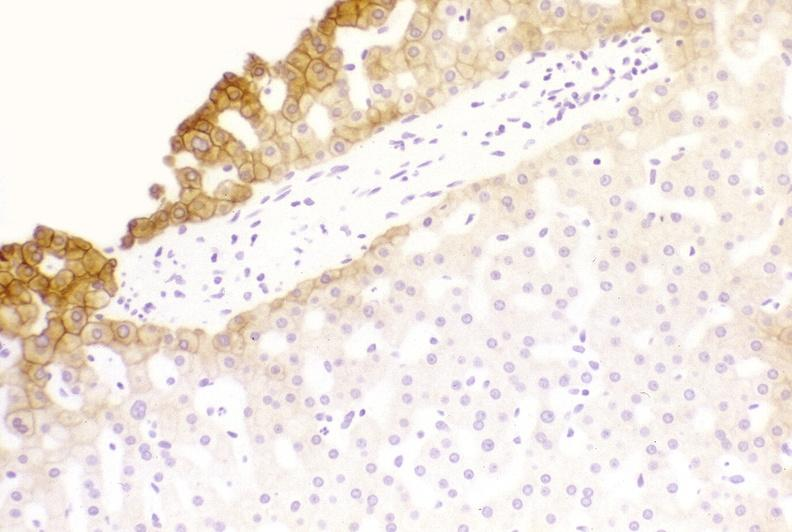does polyarteritis nodosa show low molecular weight keratin?
Answer the question using a single word or phrase. No 